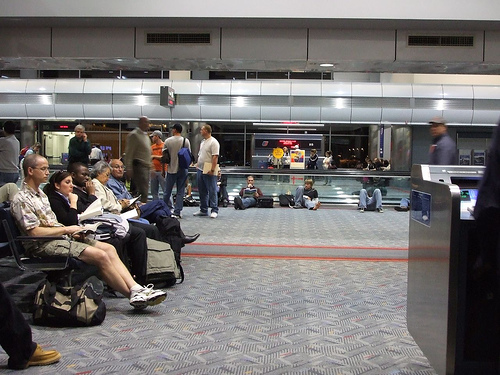<image>
Can you confirm if the hat is on the man? No. The hat is not positioned on the man. They may be near each other, but the hat is not supported by or resting on top of the man. Where is the men in relation to the women? Is it on the women? No. The men is not positioned on the women. They may be near each other, but the men is not supported by or resting on top of the women. Is the shoe on the girl? No. The shoe is not positioned on the girl. They may be near each other, but the shoe is not supported by or resting on top of the girl. 